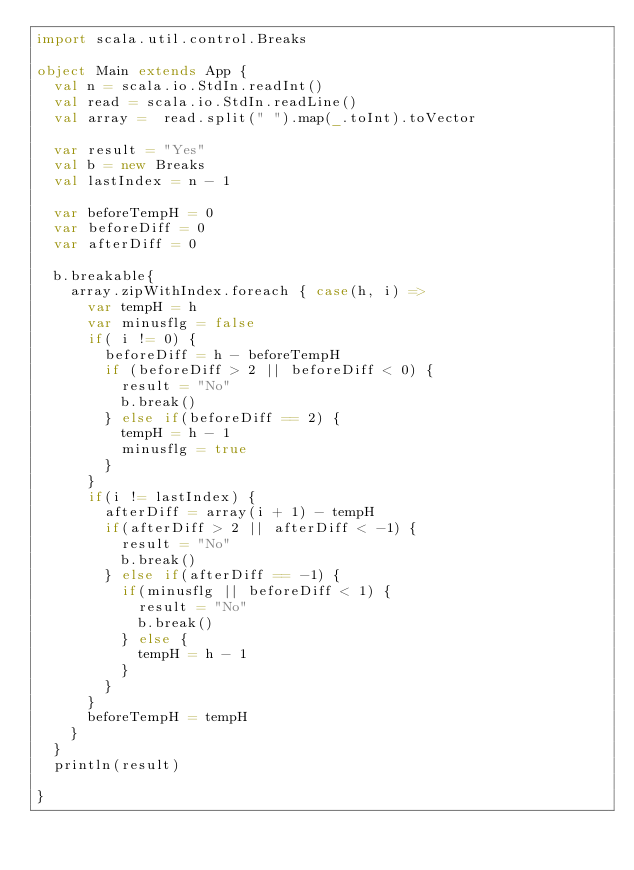<code> <loc_0><loc_0><loc_500><loc_500><_Scala_>import scala.util.control.Breaks

object Main extends App {
  val n = scala.io.StdIn.readInt()
  val read = scala.io.StdIn.readLine()
  val array =  read.split(" ").map(_.toInt).toVector

  var result = "Yes"
  val b = new Breaks
  val lastIndex = n - 1

  var beforeTempH = 0
  var beforeDiff = 0
  var afterDiff = 0

  b.breakable{
    array.zipWithIndex.foreach { case(h, i) =>
      var tempH = h
      var minusflg = false
      if( i != 0) {
        beforeDiff = h - beforeTempH
        if (beforeDiff > 2 || beforeDiff < 0) {
          result = "No"
          b.break()
        } else if(beforeDiff == 2) {
          tempH = h - 1
          minusflg = true
        }
      }
      if(i != lastIndex) {
        afterDiff = array(i + 1) - tempH
        if(afterDiff > 2 || afterDiff < -1) {
          result = "No"
          b.break()
        } else if(afterDiff == -1) {
          if(minusflg || beforeDiff < 1) {
            result = "No"
            b.break()
          } else {
            tempH = h - 1
          }
        }
      }
      beforeTempH = tempH
    }
  }
  println(result)

}</code> 